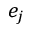Convert formula to latex. <formula><loc_0><loc_0><loc_500><loc_500>e _ { j }</formula> 